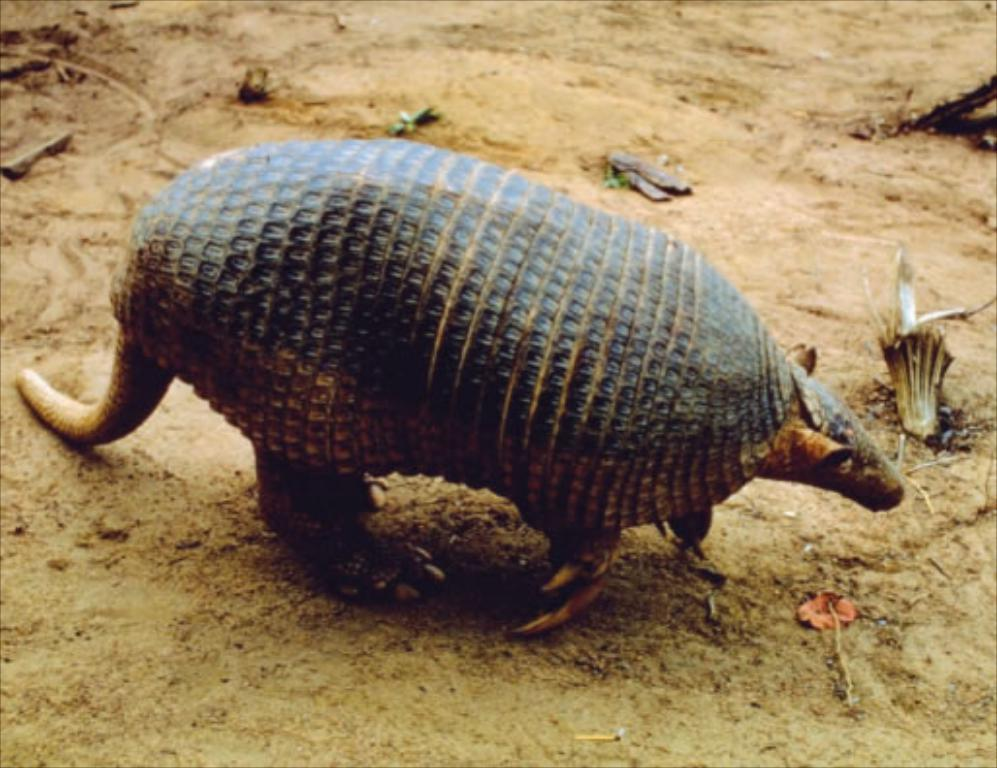What is the main subject in the center of the image? There is an animal in the center of the image. What type of terrain is visible at the bottom of the image? There is sand at the bottom of the image. How many pizzas are being served on the island in the image? There is no island or pizzas present in the image; it features an animal and sand. What type of society can be observed interacting with the animal on the island in the image? There is no society or island present in the image, and therefore no such interaction can be observed. 